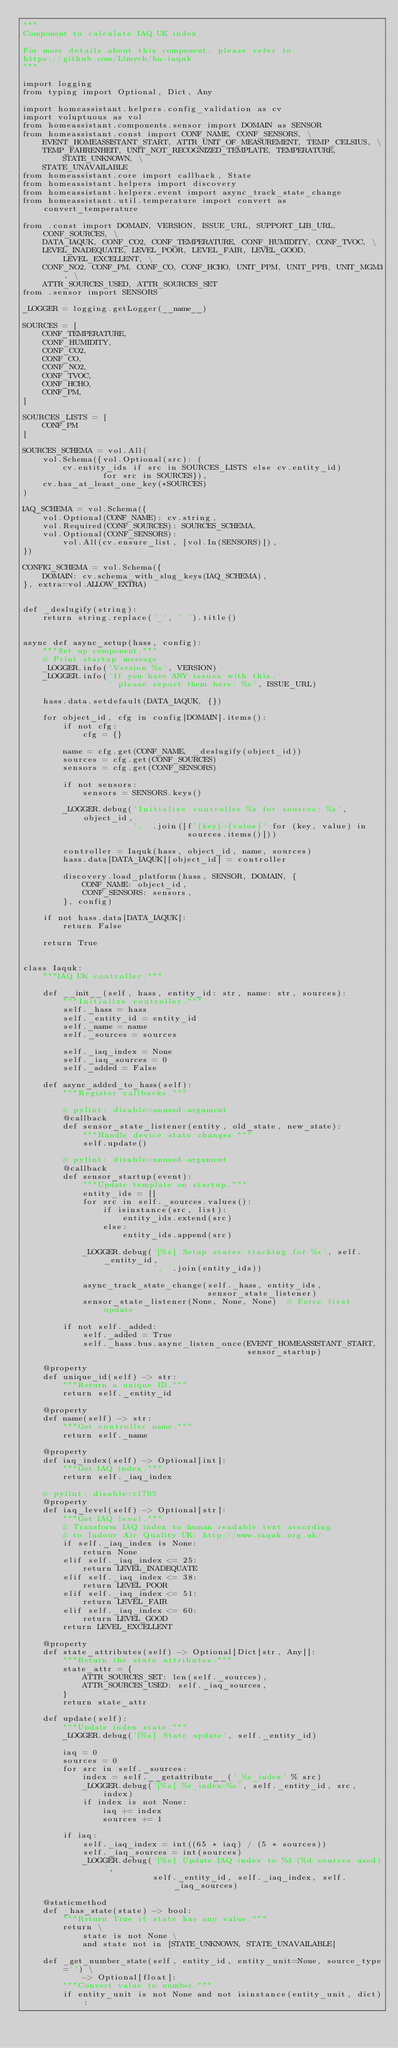<code> <loc_0><loc_0><loc_500><loc_500><_Python_>"""
Component to calculate IAQ UK index.

For more details about this component, please refer to
https://github.com/Limych/ha-iaquk
"""

import logging
from typing import Optional, Dict, Any

import homeassistant.helpers.config_validation as cv
import voluptuous as vol
from homeassistant.components.sensor import DOMAIN as SENSOR
from homeassistant.const import CONF_NAME, CONF_SENSORS, \
    EVENT_HOMEASSISTANT_START, ATTR_UNIT_OF_MEASUREMENT, TEMP_CELSIUS, \
    TEMP_FAHRENHEIT, UNIT_NOT_RECOGNIZED_TEMPLATE, TEMPERATURE, STATE_UNKNOWN, \
    STATE_UNAVAILABLE
from homeassistant.core import callback, State
from homeassistant.helpers import discovery
from homeassistant.helpers.event import async_track_state_change
from homeassistant.util.temperature import convert as convert_temperature

from .const import DOMAIN, VERSION, ISSUE_URL, SUPPORT_LIB_URL, CONF_SOURCES, \
    DATA_IAQUK, CONF_CO2, CONF_TEMPERATURE, CONF_HUMIDITY, CONF_TVOC, \
    LEVEL_INADEQUATE, LEVEL_POOR, LEVEL_FAIR, LEVEL_GOOD, LEVEL_EXCELLENT, \
    CONF_NO2, CONF_PM, CONF_CO, CONF_HCHO, UNIT_PPM, UNIT_PPB, UNIT_MGM3, \
    ATTR_SOURCES_USED, ATTR_SOURCES_SET
from .sensor import SENSORS

_LOGGER = logging.getLogger(__name__)

SOURCES = [
    CONF_TEMPERATURE,
    CONF_HUMIDITY,
    CONF_CO2,
    CONF_CO,
    CONF_NO2,
    CONF_TVOC,
    CONF_HCHO,
    CONF_PM,
]

SOURCES_LISTS = [
    CONF_PM
]

SOURCES_SCHEMA = vol.All(
    vol.Schema({vol.Optional(src): (
        cv.entity_ids if src in SOURCES_LISTS else cv.entity_id)
                for src in SOURCES}),
    cv.has_at_least_one_key(*SOURCES)
)

IAQ_SCHEMA = vol.Schema({
    vol.Optional(CONF_NAME): cv.string,
    vol.Required(CONF_SOURCES): SOURCES_SCHEMA,
    vol.Optional(CONF_SENSORS):
        vol.All(cv.ensure_list, [vol.In(SENSORS)]),
})

CONFIG_SCHEMA = vol.Schema({
    DOMAIN: cv.schema_with_slug_keys(IAQ_SCHEMA),
}, extra=vol.ALLOW_EXTRA)


def _deslugify(string):
    return string.replace('_', ' ').title()


async def async_setup(hass, config):
    """Set up component."""
    # Print startup message
    _LOGGER.info('Version %s', VERSION)
    _LOGGER.info('If you have ANY issues with this,'
                 ' please report them here: %s', ISSUE_URL)

    hass.data.setdefault(DATA_IAQUK, {})

    for object_id, cfg in config[DOMAIN].items():
        if not cfg:
            cfg = {}

        name = cfg.get(CONF_NAME, _deslugify(object_id))
        sources = cfg.get(CONF_SOURCES)
        sensors = cfg.get(CONF_SENSORS)

        if not sensors:
            sensors = SENSORS.keys()

        _LOGGER.debug('Initialize controller %s for sources: %s', object_id,
                      ', '.join([f'{key}={value}' for (key, value) in
                                 sources.items()]))

        controller = Iaquk(hass, object_id, name, sources)
        hass.data[DATA_IAQUK][object_id] = controller

        discovery.load_platform(hass, SENSOR, DOMAIN, {
            CONF_NAME: object_id,
            CONF_SENSORS: sensors,
        }, config)

    if not hass.data[DATA_IAQUK]:
        return False

    return True


class Iaquk:
    """IAQ UK controller."""

    def __init__(self, hass, entity_id: str, name: str, sources):
        """Initialize controller."""
        self._hass = hass
        self._entity_id = entity_id
        self._name = name
        self._sources = sources

        self._iaq_index = None
        self._iaq_sources = 0
        self._added = False

    def async_added_to_hass(self):
        """Register callbacks."""

        # pylint: disable=unused-argument
        @callback
        def sensor_state_listener(entity, old_state, new_state):
            """Handle device state changes."""
            self.update()

        # pylint: disable=unused-argument
        @callback
        def sensor_startup(event):
            """Update template on startup."""
            entity_ids = []
            for src in self._sources.values():
                if isinstance(src, list):
                    entity_ids.extend(src)
                else:
                    entity_ids.append(src)

            _LOGGER.debug('[%s] Setup states tracking for %s', self._entity_id,
                          ', '.join(entity_ids))

            async_track_state_change(self._hass, entity_ids,
                                     sensor_state_listener)
            sensor_state_listener(None, None, None)  # Force first update

        if not self._added:
            self._added = True
            self._hass.bus.async_listen_once(EVENT_HOMEASSISTANT_START,
                                             sensor_startup)

    @property
    def unique_id(self) -> str:
        """Return a unique ID."""
        return self._entity_id

    @property
    def name(self) -> str:
        """Get controller name."""
        return self._name

    @property
    def iaq_index(self) -> Optional[int]:
        """Get IAQ index."""
        return self._iaq_index

    # pylint: disable=r1705
    @property
    def iaq_level(self) -> Optional[str]:
        """Get IAQ level."""
        # Transform IAQ index to human readable text according
        # to Indoor Air Quality UK: http://www.iaquk.org.uk/
        if self._iaq_index is None:
            return None
        elif self._iaq_index <= 25:
            return LEVEL_INADEQUATE
        elif self._iaq_index <= 38:
            return LEVEL_POOR
        elif self._iaq_index <= 51:
            return LEVEL_FAIR
        elif self._iaq_index <= 60:
            return LEVEL_GOOD
        return LEVEL_EXCELLENT

    @property
    def state_attributes(self) -> Optional[Dict[str, Any]]:
        """Return the state attributes."""
        state_attr = {
            ATTR_SOURCES_SET: len(self._sources),
            ATTR_SOURCES_USED: self._iaq_sources,
        }
        return state_attr

    def update(self):
        """Update index state."""
        _LOGGER.debug('[%s] State update', self._entity_id)

        iaq = 0
        sources = 0
        for src in self._sources:
            index = self.__getattribute__('_%s_index' % src)
            _LOGGER.debug('[%s] %s_index=%s', self._entity_id, src, index)
            if index is not None:
                iaq += index
                sources += 1

        if iaq:
            self._iaq_index = int((65 * iaq) / (5 * sources))
            self._iaq_sources = int(sources)
            _LOGGER.debug('[%s] Update IAQ index to %d (%d sources used)',
                          self._entity_id, self._iaq_index, self._iaq_sources)

    @staticmethod
    def _has_state(state) -> bool:
        """Return True if state has any value."""
        return \
            state is not None \
            and state not in [STATE_UNKNOWN, STATE_UNAVAILABLE]

    def _get_number_state(self, entity_id, entity_unit=None, source_type='') \
            -> Optional[float]:
        """Convert value to number."""
        if entity_unit is not None and not isinstance(entity_unit, dict):</code> 